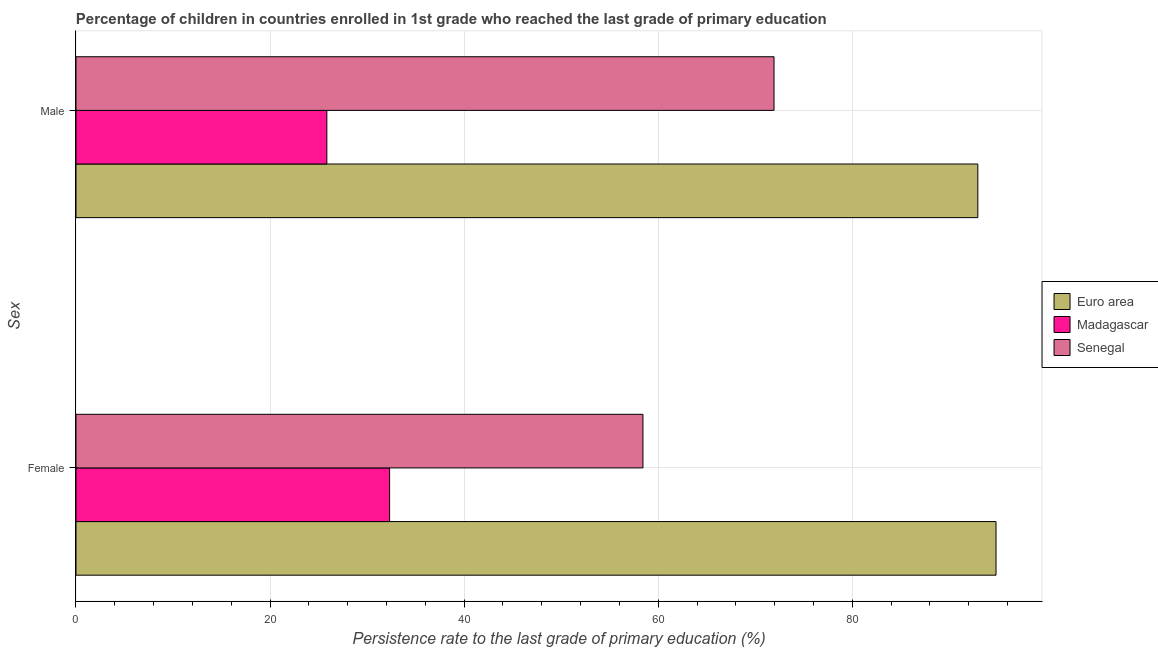How many different coloured bars are there?
Your response must be concise. 3. Are the number of bars per tick equal to the number of legend labels?
Your response must be concise. Yes. How many bars are there on the 2nd tick from the bottom?
Give a very brief answer. 3. What is the label of the 1st group of bars from the top?
Your response must be concise. Male. What is the persistence rate of female students in Madagascar?
Give a very brief answer. 32.32. Across all countries, what is the maximum persistence rate of female students?
Your answer should be compact. 94.81. Across all countries, what is the minimum persistence rate of female students?
Keep it short and to the point. 32.32. In which country was the persistence rate of female students minimum?
Offer a terse response. Madagascar. What is the total persistence rate of male students in the graph?
Give a very brief answer. 190.71. What is the difference between the persistence rate of female students in Senegal and that in Euro area?
Provide a succinct answer. -36.38. What is the difference between the persistence rate of male students in Euro area and the persistence rate of female students in Madagascar?
Offer a very short reply. 60.61. What is the average persistence rate of female students per country?
Offer a terse response. 61.85. What is the difference between the persistence rate of male students and persistence rate of female students in Senegal?
Your answer should be very brief. 13.51. In how many countries, is the persistence rate of female students greater than 20 %?
Offer a very short reply. 3. What is the ratio of the persistence rate of female students in Madagascar to that in Euro area?
Ensure brevity in your answer.  0.34. What does the 2nd bar from the bottom in Female represents?
Ensure brevity in your answer.  Madagascar. How many countries are there in the graph?
Your answer should be very brief. 3. What is the difference between two consecutive major ticks on the X-axis?
Offer a very short reply. 20. Does the graph contain any zero values?
Offer a terse response. No. Does the graph contain grids?
Your response must be concise. Yes. How are the legend labels stacked?
Offer a terse response. Vertical. What is the title of the graph?
Provide a succinct answer. Percentage of children in countries enrolled in 1st grade who reached the last grade of primary education. What is the label or title of the X-axis?
Provide a succinct answer. Persistence rate to the last grade of primary education (%). What is the label or title of the Y-axis?
Provide a short and direct response. Sex. What is the Persistence rate to the last grade of primary education (%) in Euro area in Female?
Give a very brief answer. 94.81. What is the Persistence rate to the last grade of primary education (%) of Madagascar in Female?
Your answer should be very brief. 32.32. What is the Persistence rate to the last grade of primary education (%) in Senegal in Female?
Make the answer very short. 58.42. What is the Persistence rate to the last grade of primary education (%) of Euro area in Male?
Your answer should be very brief. 92.93. What is the Persistence rate to the last grade of primary education (%) in Madagascar in Male?
Your answer should be very brief. 25.85. What is the Persistence rate to the last grade of primary education (%) in Senegal in Male?
Your answer should be very brief. 71.93. Across all Sex, what is the maximum Persistence rate to the last grade of primary education (%) in Euro area?
Offer a very short reply. 94.81. Across all Sex, what is the maximum Persistence rate to the last grade of primary education (%) of Madagascar?
Offer a terse response. 32.32. Across all Sex, what is the maximum Persistence rate to the last grade of primary education (%) in Senegal?
Keep it short and to the point. 71.93. Across all Sex, what is the minimum Persistence rate to the last grade of primary education (%) in Euro area?
Offer a very short reply. 92.93. Across all Sex, what is the minimum Persistence rate to the last grade of primary education (%) in Madagascar?
Ensure brevity in your answer.  25.85. Across all Sex, what is the minimum Persistence rate to the last grade of primary education (%) of Senegal?
Your response must be concise. 58.42. What is the total Persistence rate to the last grade of primary education (%) of Euro area in the graph?
Ensure brevity in your answer.  187.74. What is the total Persistence rate to the last grade of primary education (%) in Madagascar in the graph?
Provide a succinct answer. 58.17. What is the total Persistence rate to the last grade of primary education (%) of Senegal in the graph?
Your answer should be compact. 130.35. What is the difference between the Persistence rate to the last grade of primary education (%) of Euro area in Female and that in Male?
Give a very brief answer. 1.87. What is the difference between the Persistence rate to the last grade of primary education (%) in Madagascar in Female and that in Male?
Keep it short and to the point. 6.47. What is the difference between the Persistence rate to the last grade of primary education (%) of Senegal in Female and that in Male?
Provide a short and direct response. -13.51. What is the difference between the Persistence rate to the last grade of primary education (%) in Euro area in Female and the Persistence rate to the last grade of primary education (%) in Madagascar in Male?
Offer a very short reply. 68.96. What is the difference between the Persistence rate to the last grade of primary education (%) of Euro area in Female and the Persistence rate to the last grade of primary education (%) of Senegal in Male?
Give a very brief answer. 22.88. What is the difference between the Persistence rate to the last grade of primary education (%) in Madagascar in Female and the Persistence rate to the last grade of primary education (%) in Senegal in Male?
Your response must be concise. -39.61. What is the average Persistence rate to the last grade of primary education (%) of Euro area per Sex?
Give a very brief answer. 93.87. What is the average Persistence rate to the last grade of primary education (%) of Madagascar per Sex?
Ensure brevity in your answer.  29.08. What is the average Persistence rate to the last grade of primary education (%) in Senegal per Sex?
Give a very brief answer. 65.18. What is the difference between the Persistence rate to the last grade of primary education (%) of Euro area and Persistence rate to the last grade of primary education (%) of Madagascar in Female?
Give a very brief answer. 62.49. What is the difference between the Persistence rate to the last grade of primary education (%) in Euro area and Persistence rate to the last grade of primary education (%) in Senegal in Female?
Offer a very short reply. 36.38. What is the difference between the Persistence rate to the last grade of primary education (%) of Madagascar and Persistence rate to the last grade of primary education (%) of Senegal in Female?
Offer a terse response. -26.11. What is the difference between the Persistence rate to the last grade of primary education (%) of Euro area and Persistence rate to the last grade of primary education (%) of Madagascar in Male?
Give a very brief answer. 67.08. What is the difference between the Persistence rate to the last grade of primary education (%) of Euro area and Persistence rate to the last grade of primary education (%) of Senegal in Male?
Provide a short and direct response. 21. What is the difference between the Persistence rate to the last grade of primary education (%) of Madagascar and Persistence rate to the last grade of primary education (%) of Senegal in Male?
Ensure brevity in your answer.  -46.08. What is the ratio of the Persistence rate to the last grade of primary education (%) of Euro area in Female to that in Male?
Provide a succinct answer. 1.02. What is the ratio of the Persistence rate to the last grade of primary education (%) of Madagascar in Female to that in Male?
Offer a terse response. 1.25. What is the ratio of the Persistence rate to the last grade of primary education (%) of Senegal in Female to that in Male?
Make the answer very short. 0.81. What is the difference between the highest and the second highest Persistence rate to the last grade of primary education (%) in Euro area?
Give a very brief answer. 1.87. What is the difference between the highest and the second highest Persistence rate to the last grade of primary education (%) of Madagascar?
Provide a succinct answer. 6.47. What is the difference between the highest and the second highest Persistence rate to the last grade of primary education (%) of Senegal?
Your answer should be compact. 13.51. What is the difference between the highest and the lowest Persistence rate to the last grade of primary education (%) in Euro area?
Give a very brief answer. 1.87. What is the difference between the highest and the lowest Persistence rate to the last grade of primary education (%) in Madagascar?
Ensure brevity in your answer.  6.47. What is the difference between the highest and the lowest Persistence rate to the last grade of primary education (%) in Senegal?
Your response must be concise. 13.51. 